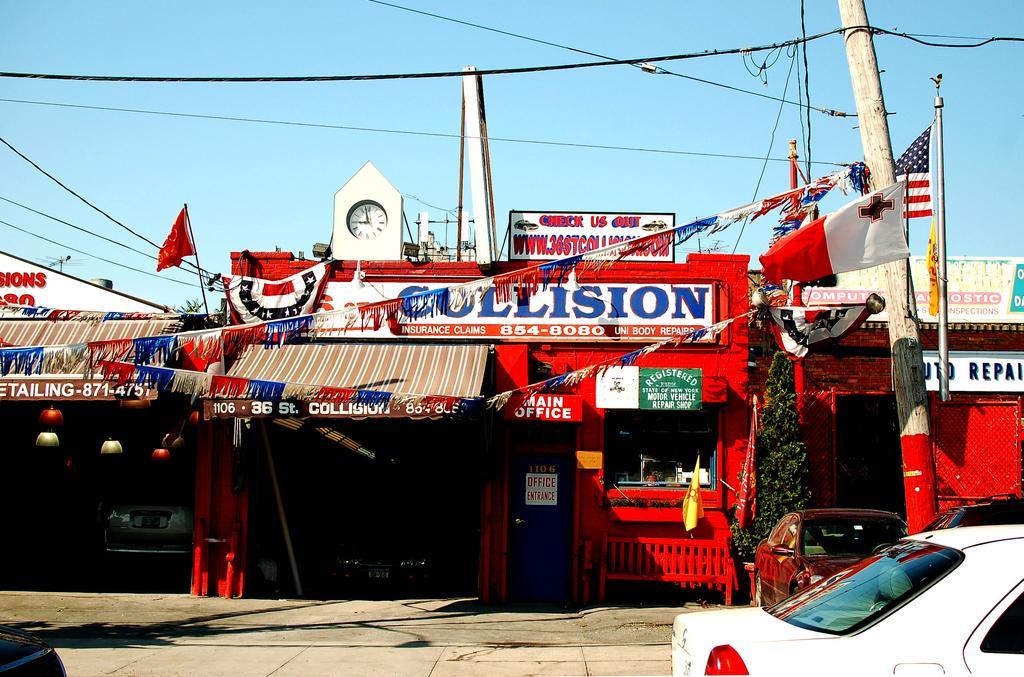Describe this image in one or two sentences. In this picture we can see there are vehicles on the road. Behind the vehicles there is a bench, shops, name boards, flags, poles, a tree, cables and some decorative items. Behind the shops, there is the sky. 